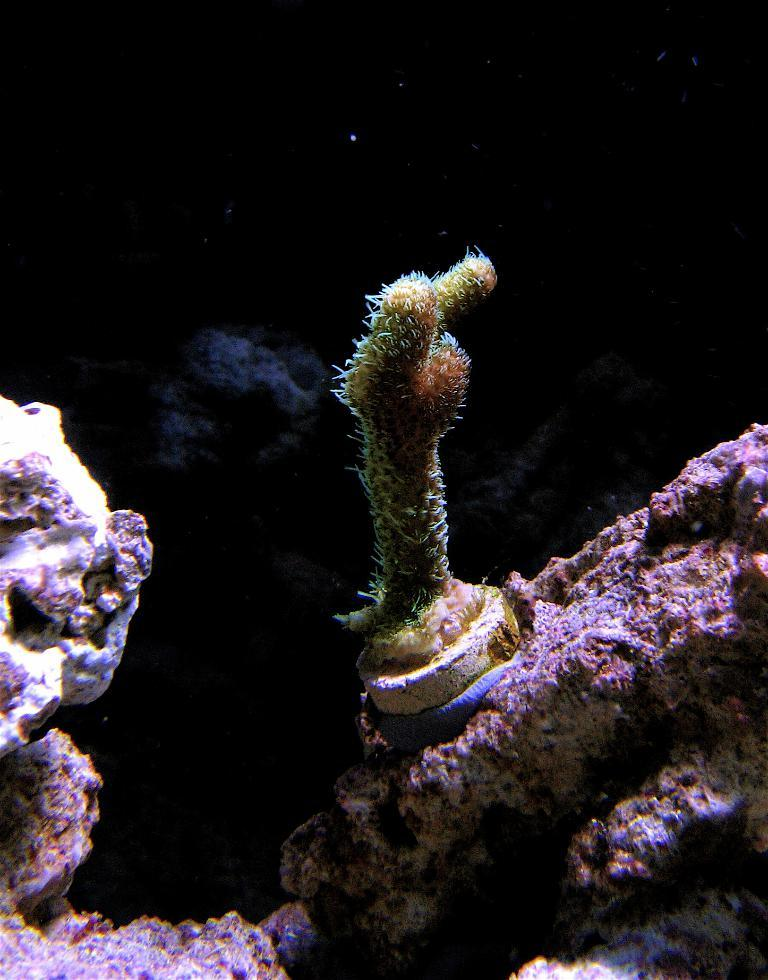What type of plant is in the image? There is an aquatic plant in the image. Where is the aquatic plant located? The aquatic plant is on a rock. What is the color of the background in the image? The background of the image is dark. How does the aquatic plant pull the rock in the image? The aquatic plant does not pull the rock in the image; it is simply located on the rock. Can you see a fork in the image? There is no fork present in the image. 